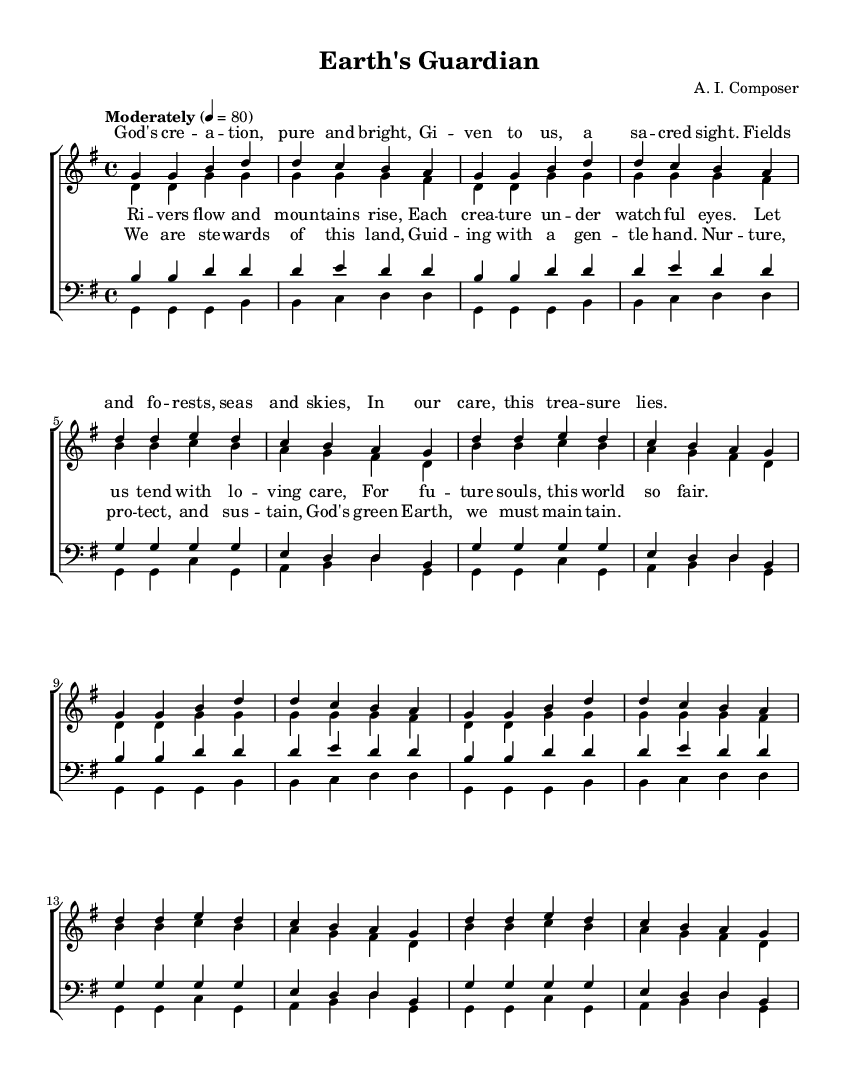What is the key signature of this music? The key signature is G major, which has one sharp (F#). You can determine this by identifying the sharp notes indicated at the beginning of the staff.
Answer: G major What is the time signature of this music? The time signature is 4/4, which is indicated at the beginning of the score. It denotes that there are four beats per measure, with a quarter note receiving one beat.
Answer: 4/4 What is the tempo marking for this piece? The tempo marking is "Moderately" with a tempo of 80 beats per minute, which is shown at the beginning of the music. This instructs the performers to play at a moderate speed.
Answer: Moderately 4 = 80 What is the title of this hymn? The title of the hymn is "Earth's Guardian," as indicated in the header section of the music score. This gives an idea of the thematic content related to environmental stewardship.
Answer: Earth's Guardian How many verses are in this hymn? There are two verses present, as indicated by the labels "verseOne" and "verseTwo" in the complexity of the musical composition. Each verse has different lyrics reflecting similar messages about creation care.
Answer: Two What main theme is presented in the lyrics of this hymn? The main theme is environmental stewardship and care for creation, discussed through the imagery of nature, suggesting responsibility towards the earth. This can be inferred from the lyrics that speak of nurturing and protecting what God has created.
Answer: Environmental stewardship Which voice part starts with the lyrics "God's creation, pure and bright"? The soprano voice part starts with this lyric. This can be determined by looking at the score, where the soprano part is aligned with these words in the verse.
Answer: Soprano 